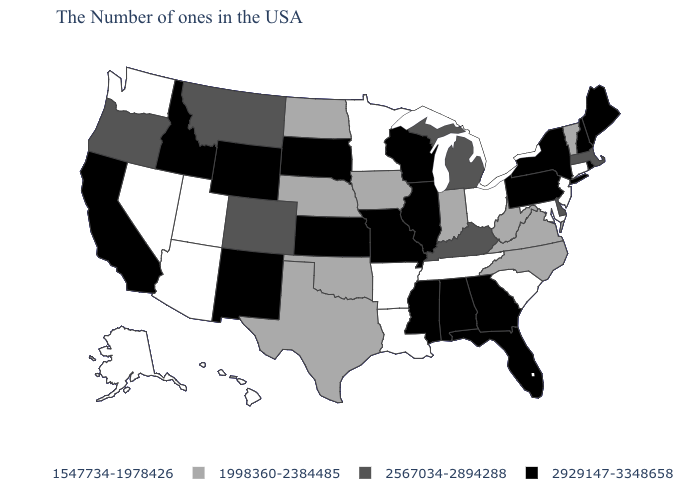What is the value of Maine?
Answer briefly. 2929147-3348658. Among the states that border Oklahoma , does Colorado have the lowest value?
Write a very short answer. No. Name the states that have a value in the range 1998360-2384485?
Write a very short answer. Vermont, Virginia, North Carolina, West Virginia, Indiana, Iowa, Nebraska, Oklahoma, Texas, North Dakota. What is the value of Idaho?
Give a very brief answer. 2929147-3348658. What is the value of Texas?
Give a very brief answer. 1998360-2384485. Does Indiana have the highest value in the MidWest?
Concise answer only. No. Does South Carolina have the highest value in the USA?
Write a very short answer. No. Among the states that border Connecticut , which have the lowest value?
Give a very brief answer. Massachusetts. What is the value of Virginia?
Be succinct. 1998360-2384485. Does Michigan have a lower value than Illinois?
Quick response, please. Yes. Name the states that have a value in the range 1547734-1978426?
Concise answer only. Connecticut, New Jersey, Maryland, South Carolina, Ohio, Tennessee, Louisiana, Arkansas, Minnesota, Utah, Arizona, Nevada, Washington, Alaska, Hawaii. What is the value of Florida?
Give a very brief answer. 2929147-3348658. What is the value of Rhode Island?
Write a very short answer. 2929147-3348658. Among the states that border Utah , which have the lowest value?
Quick response, please. Arizona, Nevada. What is the value of North Carolina?
Answer briefly. 1998360-2384485. 